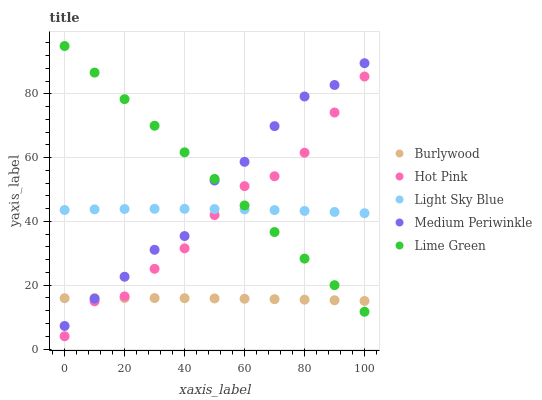Does Burlywood have the minimum area under the curve?
Answer yes or no. Yes. Does Lime Green have the maximum area under the curve?
Answer yes or no. Yes. Does Hot Pink have the minimum area under the curve?
Answer yes or no. No. Does Hot Pink have the maximum area under the curve?
Answer yes or no. No. Is Lime Green the smoothest?
Answer yes or no. Yes. Is Medium Periwinkle the roughest?
Answer yes or no. Yes. Is Hot Pink the smoothest?
Answer yes or no. No. Is Hot Pink the roughest?
Answer yes or no. No. Does Hot Pink have the lowest value?
Answer yes or no. Yes. Does Lime Green have the lowest value?
Answer yes or no. No. Does Lime Green have the highest value?
Answer yes or no. Yes. Does Hot Pink have the highest value?
Answer yes or no. No. Is Burlywood less than Light Sky Blue?
Answer yes or no. Yes. Is Light Sky Blue greater than Burlywood?
Answer yes or no. Yes. Does Hot Pink intersect Light Sky Blue?
Answer yes or no. Yes. Is Hot Pink less than Light Sky Blue?
Answer yes or no. No. Is Hot Pink greater than Light Sky Blue?
Answer yes or no. No. Does Burlywood intersect Light Sky Blue?
Answer yes or no. No. 